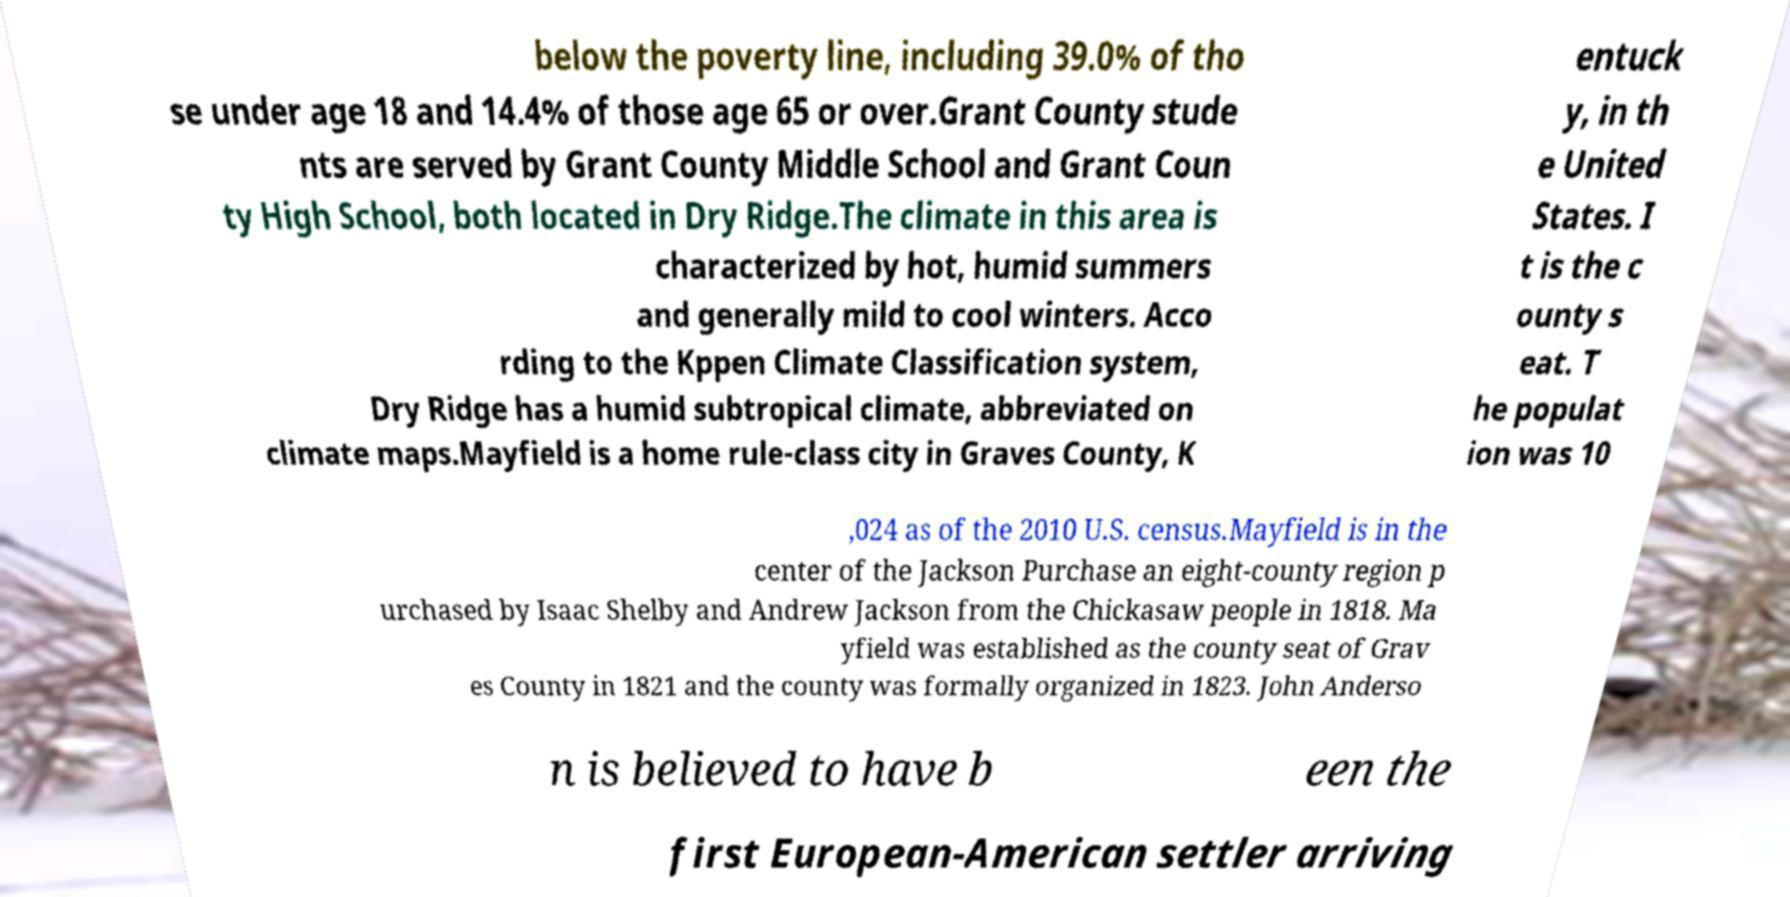There's text embedded in this image that I need extracted. Can you transcribe it verbatim? below the poverty line, including 39.0% of tho se under age 18 and 14.4% of those age 65 or over.Grant County stude nts are served by Grant County Middle School and Grant Coun ty High School, both located in Dry Ridge.The climate in this area is characterized by hot, humid summers and generally mild to cool winters. Acco rding to the Kppen Climate Classification system, Dry Ridge has a humid subtropical climate, abbreviated on climate maps.Mayfield is a home rule-class city in Graves County, K entuck y, in th e United States. I t is the c ounty s eat. T he populat ion was 10 ,024 as of the 2010 U.S. census.Mayfield is in the center of the Jackson Purchase an eight-county region p urchased by Isaac Shelby and Andrew Jackson from the Chickasaw people in 1818. Ma yfield was established as the county seat of Grav es County in 1821 and the county was formally organized in 1823. John Anderso n is believed to have b een the first European-American settler arriving 